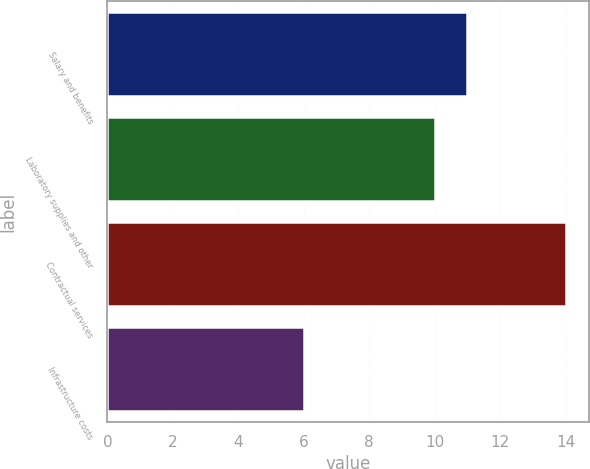<chart> <loc_0><loc_0><loc_500><loc_500><bar_chart><fcel>Salary and benefits<fcel>Laboratory supplies and other<fcel>Contractual services<fcel>Infrastructure costs<nl><fcel>11<fcel>10<fcel>14<fcel>6<nl></chart> 